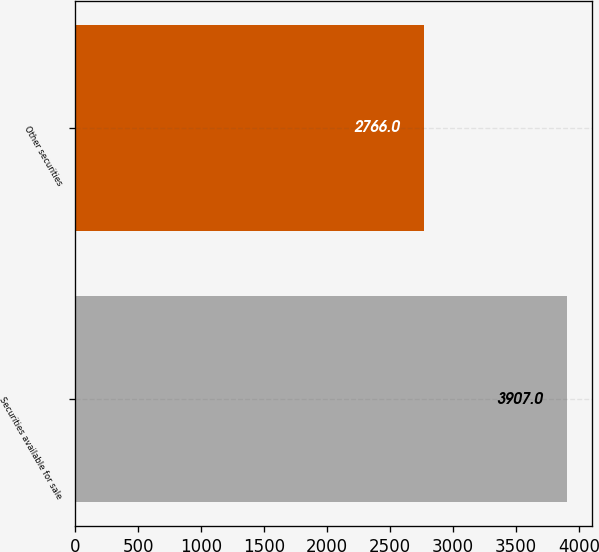<chart> <loc_0><loc_0><loc_500><loc_500><bar_chart><fcel>Securities available for sale<fcel>Other securities<nl><fcel>3907<fcel>2766<nl></chart> 